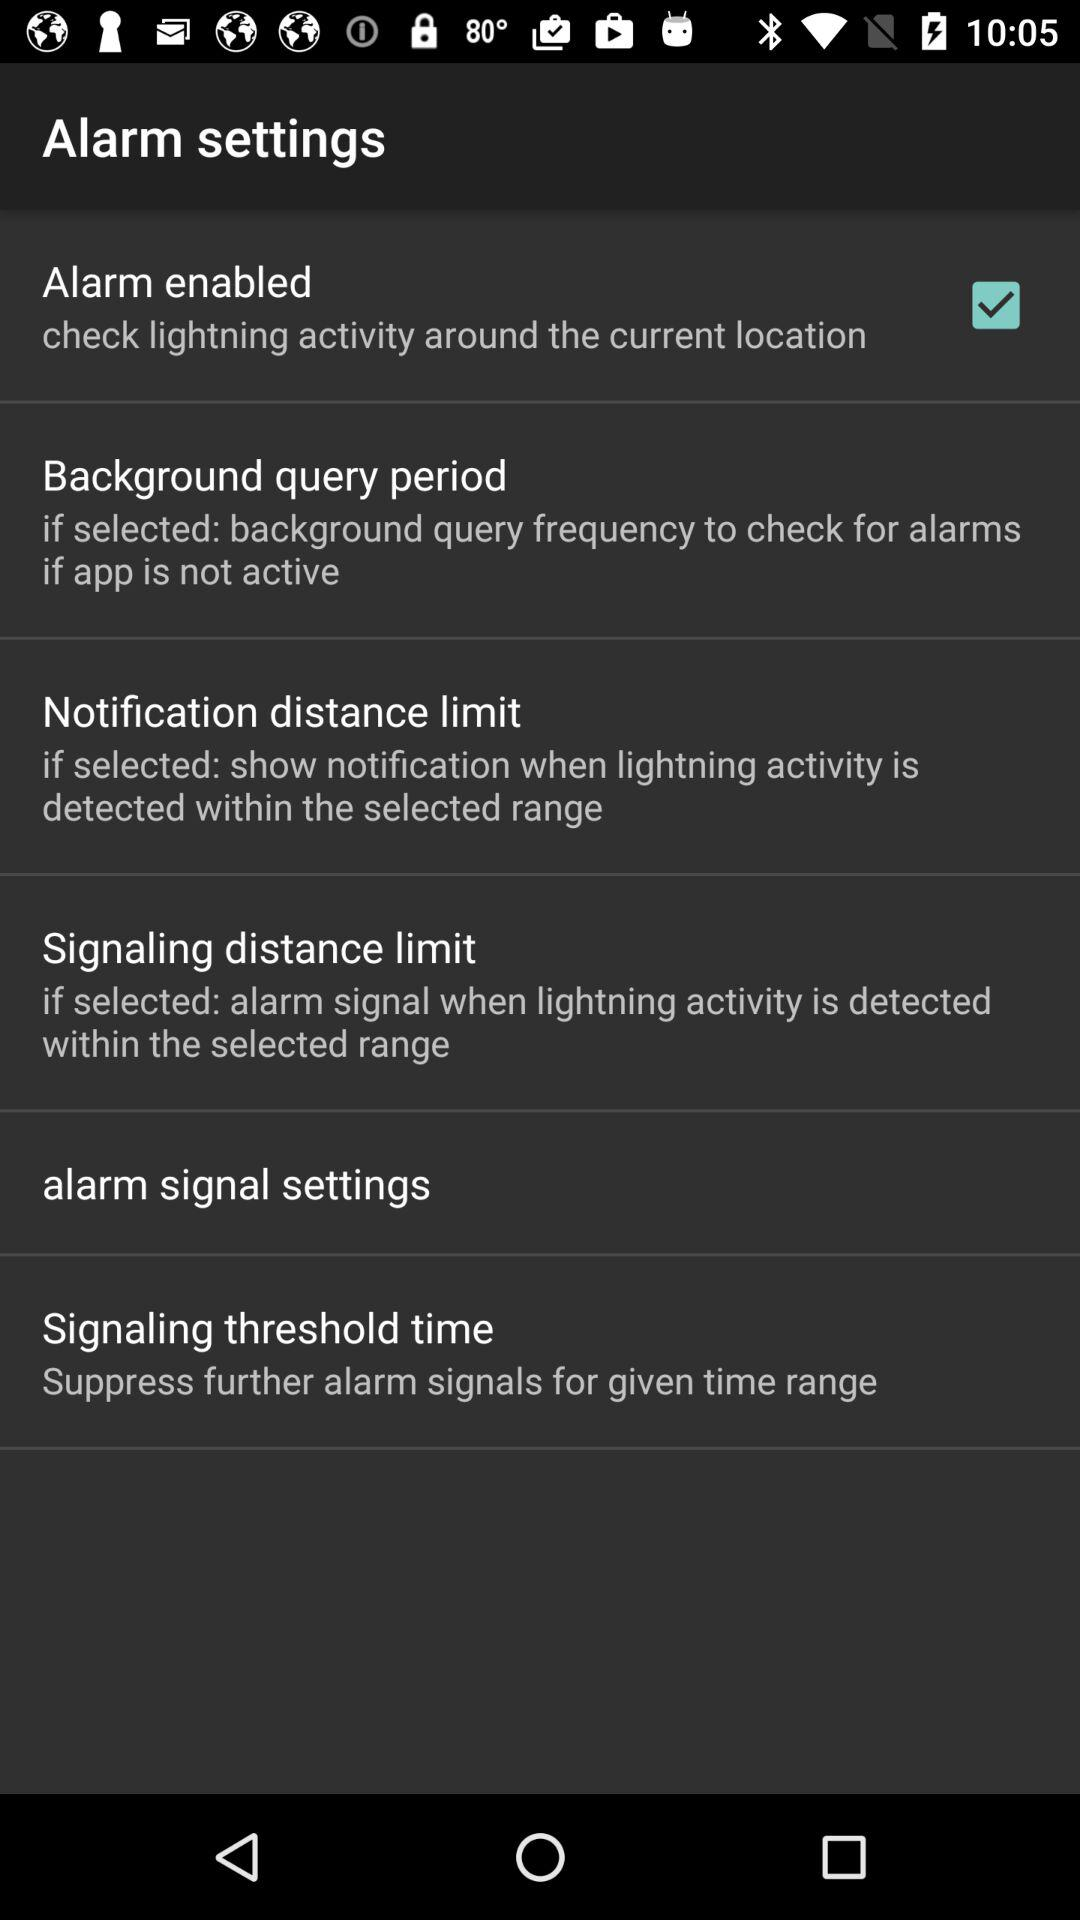Which of the alarm settings are turned on? The setting that is turned on is "Alarm enabled". 